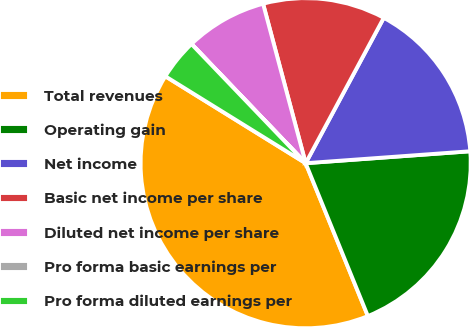<chart> <loc_0><loc_0><loc_500><loc_500><pie_chart><fcel>Total revenues<fcel>Operating gain<fcel>Net income<fcel>Basic net income per share<fcel>Diluted net income per share<fcel>Pro forma basic earnings per<fcel>Pro forma diluted earnings per<nl><fcel>39.98%<fcel>20.0%<fcel>16.0%<fcel>12.0%<fcel>8.0%<fcel>0.01%<fcel>4.01%<nl></chart> 